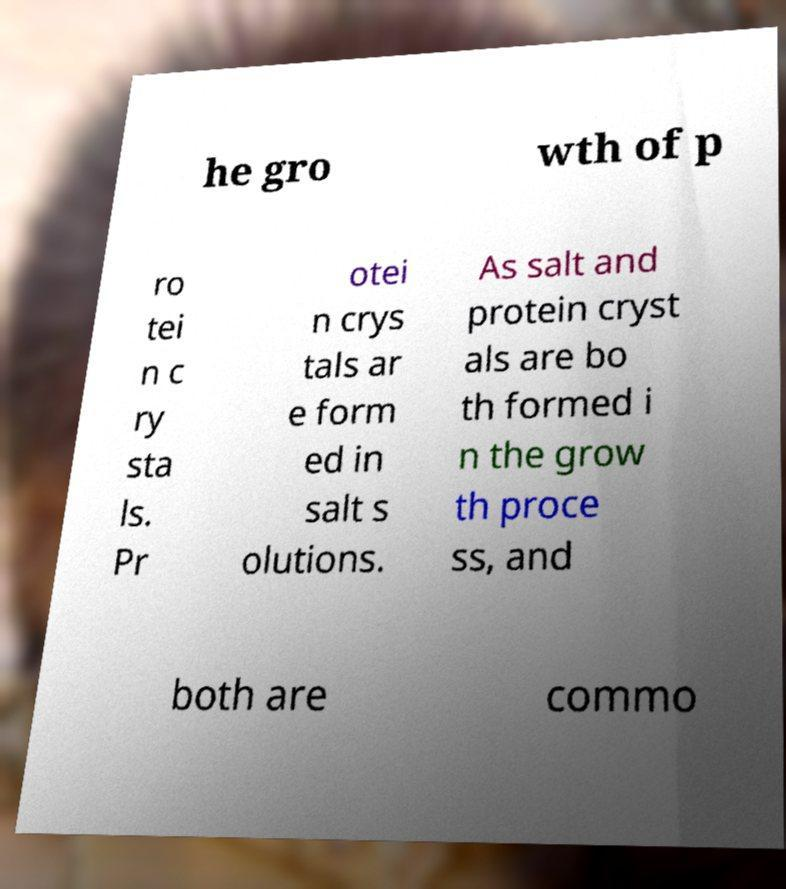For documentation purposes, I need the text within this image transcribed. Could you provide that? he gro wth of p ro tei n c ry sta ls. Pr otei n crys tals ar e form ed in salt s olutions. As salt and protein cryst als are bo th formed i n the grow th proce ss, and both are commo 